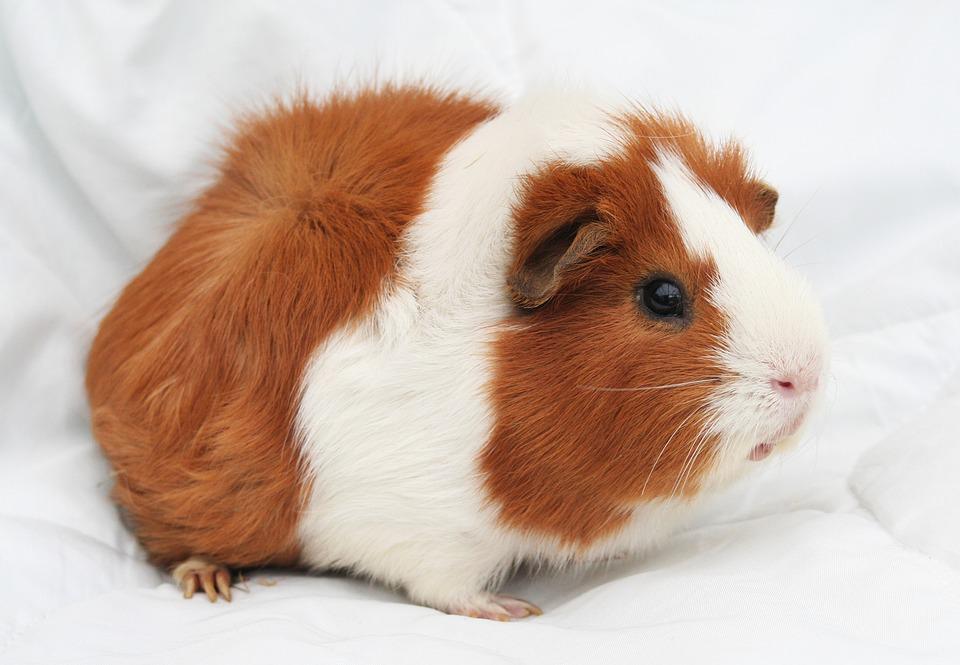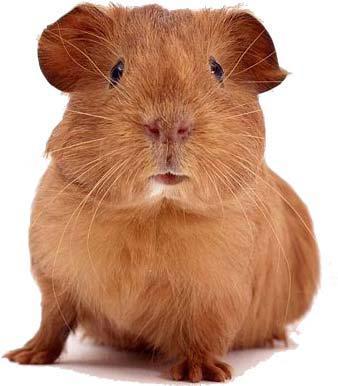The first image is the image on the left, the second image is the image on the right. Examine the images to the left and right. Is the description "At least one image contains two guinea pigs." accurate? Answer yes or no. No. 